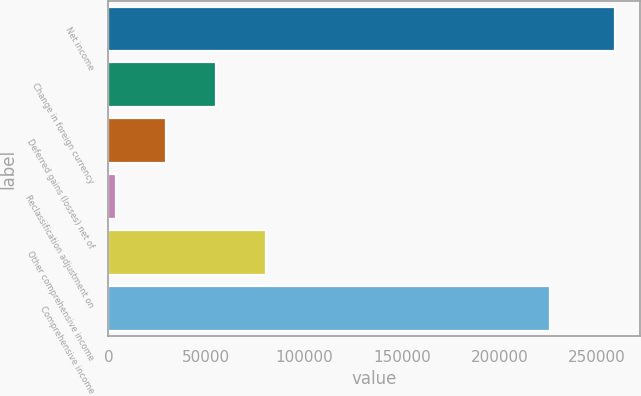Convert chart. <chart><loc_0><loc_0><loc_500><loc_500><bar_chart><fcel>Net income<fcel>Change in foreign currency<fcel>Deferred gains (losses) net of<fcel>Reclassification adjustment on<fcel>Other comprehensive income<fcel>Comprehensive income<nl><fcel>259124<fcel>54930.4<fcel>29406.2<fcel>3882<fcel>80454.6<fcel>225730<nl></chart> 